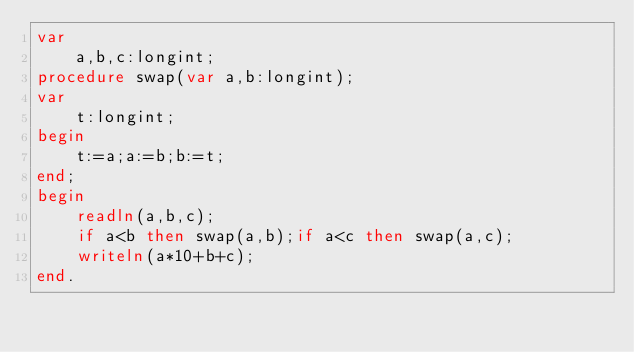Convert code to text. <code><loc_0><loc_0><loc_500><loc_500><_Pascal_>var
    a,b,c:longint;
procedure swap(var a,b:longint);
var
    t:longint;
begin
    t:=a;a:=b;b:=t;
end;
begin
    readln(a,b,c);
    if a<b then swap(a,b);if a<c then swap(a,c);
    writeln(a*10+b+c);
end.</code> 